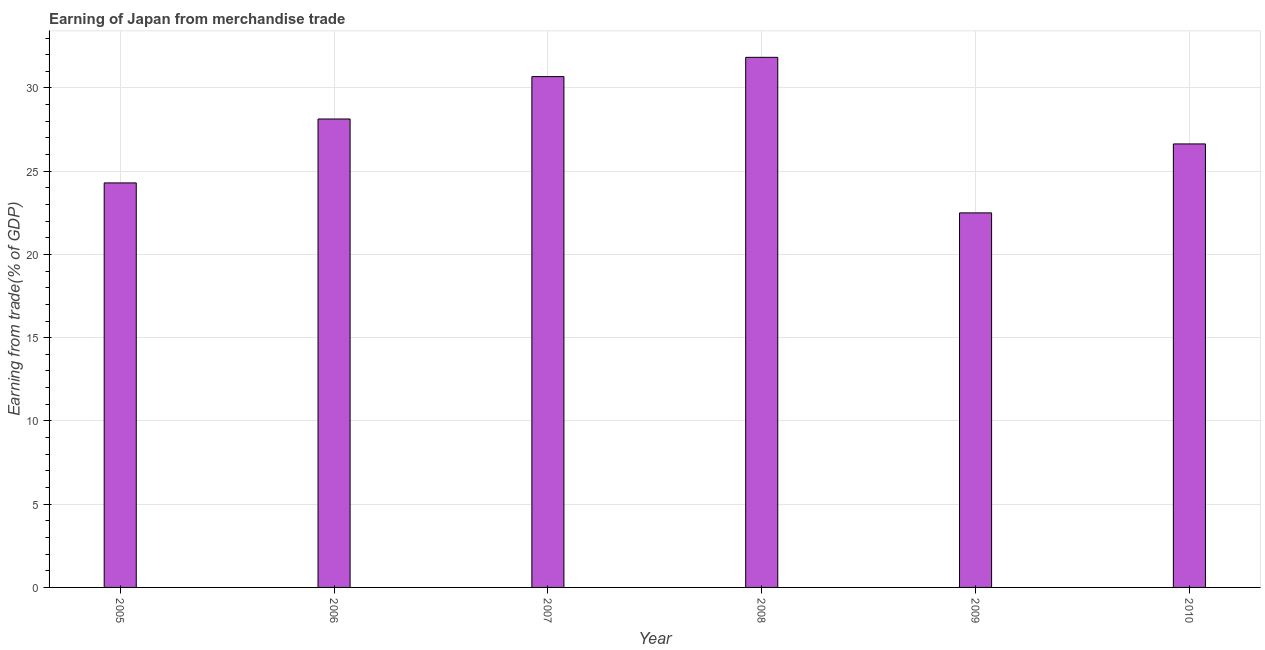Does the graph contain any zero values?
Your answer should be very brief. No. What is the title of the graph?
Offer a very short reply. Earning of Japan from merchandise trade. What is the label or title of the Y-axis?
Provide a short and direct response. Earning from trade(% of GDP). What is the earning from merchandise trade in 2007?
Make the answer very short. 30.68. Across all years, what is the maximum earning from merchandise trade?
Your answer should be compact. 31.84. Across all years, what is the minimum earning from merchandise trade?
Provide a succinct answer. 22.5. In which year was the earning from merchandise trade minimum?
Your answer should be compact. 2009. What is the sum of the earning from merchandise trade?
Keep it short and to the point. 164.09. What is the difference between the earning from merchandise trade in 2006 and 2010?
Provide a succinct answer. 1.5. What is the average earning from merchandise trade per year?
Keep it short and to the point. 27.35. What is the median earning from merchandise trade?
Keep it short and to the point. 27.39. What is the ratio of the earning from merchandise trade in 2005 to that in 2007?
Provide a short and direct response. 0.79. Is the difference between the earning from merchandise trade in 2005 and 2009 greater than the difference between any two years?
Provide a succinct answer. No. What is the difference between the highest and the second highest earning from merchandise trade?
Give a very brief answer. 1.16. What is the difference between the highest and the lowest earning from merchandise trade?
Ensure brevity in your answer.  9.34. In how many years, is the earning from merchandise trade greater than the average earning from merchandise trade taken over all years?
Provide a succinct answer. 3. How many bars are there?
Your answer should be very brief. 6. Are all the bars in the graph horizontal?
Ensure brevity in your answer.  No. What is the Earning from trade(% of GDP) of 2005?
Provide a succinct answer. 24.3. What is the Earning from trade(% of GDP) of 2006?
Provide a succinct answer. 28.14. What is the Earning from trade(% of GDP) in 2007?
Offer a very short reply. 30.68. What is the Earning from trade(% of GDP) in 2008?
Your answer should be compact. 31.84. What is the Earning from trade(% of GDP) of 2009?
Your answer should be compact. 22.5. What is the Earning from trade(% of GDP) of 2010?
Your response must be concise. 26.64. What is the difference between the Earning from trade(% of GDP) in 2005 and 2006?
Provide a succinct answer. -3.84. What is the difference between the Earning from trade(% of GDP) in 2005 and 2007?
Give a very brief answer. -6.38. What is the difference between the Earning from trade(% of GDP) in 2005 and 2008?
Your response must be concise. -7.54. What is the difference between the Earning from trade(% of GDP) in 2005 and 2009?
Keep it short and to the point. 1.8. What is the difference between the Earning from trade(% of GDP) in 2005 and 2010?
Your answer should be compact. -2.34. What is the difference between the Earning from trade(% of GDP) in 2006 and 2007?
Your answer should be compact. -2.55. What is the difference between the Earning from trade(% of GDP) in 2006 and 2008?
Ensure brevity in your answer.  -3.7. What is the difference between the Earning from trade(% of GDP) in 2006 and 2009?
Your answer should be very brief. 5.64. What is the difference between the Earning from trade(% of GDP) in 2006 and 2010?
Provide a short and direct response. 1.5. What is the difference between the Earning from trade(% of GDP) in 2007 and 2008?
Ensure brevity in your answer.  -1.16. What is the difference between the Earning from trade(% of GDP) in 2007 and 2009?
Keep it short and to the point. 8.19. What is the difference between the Earning from trade(% of GDP) in 2007 and 2010?
Keep it short and to the point. 4.04. What is the difference between the Earning from trade(% of GDP) in 2008 and 2009?
Your answer should be very brief. 9.34. What is the difference between the Earning from trade(% of GDP) in 2008 and 2010?
Keep it short and to the point. 5.2. What is the difference between the Earning from trade(% of GDP) in 2009 and 2010?
Offer a terse response. -4.14. What is the ratio of the Earning from trade(% of GDP) in 2005 to that in 2006?
Ensure brevity in your answer.  0.86. What is the ratio of the Earning from trade(% of GDP) in 2005 to that in 2007?
Your answer should be very brief. 0.79. What is the ratio of the Earning from trade(% of GDP) in 2005 to that in 2008?
Your answer should be compact. 0.76. What is the ratio of the Earning from trade(% of GDP) in 2005 to that in 2009?
Ensure brevity in your answer.  1.08. What is the ratio of the Earning from trade(% of GDP) in 2005 to that in 2010?
Your answer should be very brief. 0.91. What is the ratio of the Earning from trade(% of GDP) in 2006 to that in 2007?
Make the answer very short. 0.92. What is the ratio of the Earning from trade(% of GDP) in 2006 to that in 2008?
Keep it short and to the point. 0.88. What is the ratio of the Earning from trade(% of GDP) in 2006 to that in 2009?
Your response must be concise. 1.25. What is the ratio of the Earning from trade(% of GDP) in 2006 to that in 2010?
Keep it short and to the point. 1.06. What is the ratio of the Earning from trade(% of GDP) in 2007 to that in 2008?
Your response must be concise. 0.96. What is the ratio of the Earning from trade(% of GDP) in 2007 to that in 2009?
Offer a very short reply. 1.36. What is the ratio of the Earning from trade(% of GDP) in 2007 to that in 2010?
Ensure brevity in your answer.  1.15. What is the ratio of the Earning from trade(% of GDP) in 2008 to that in 2009?
Your response must be concise. 1.42. What is the ratio of the Earning from trade(% of GDP) in 2008 to that in 2010?
Your answer should be very brief. 1.2. What is the ratio of the Earning from trade(% of GDP) in 2009 to that in 2010?
Provide a succinct answer. 0.84. 